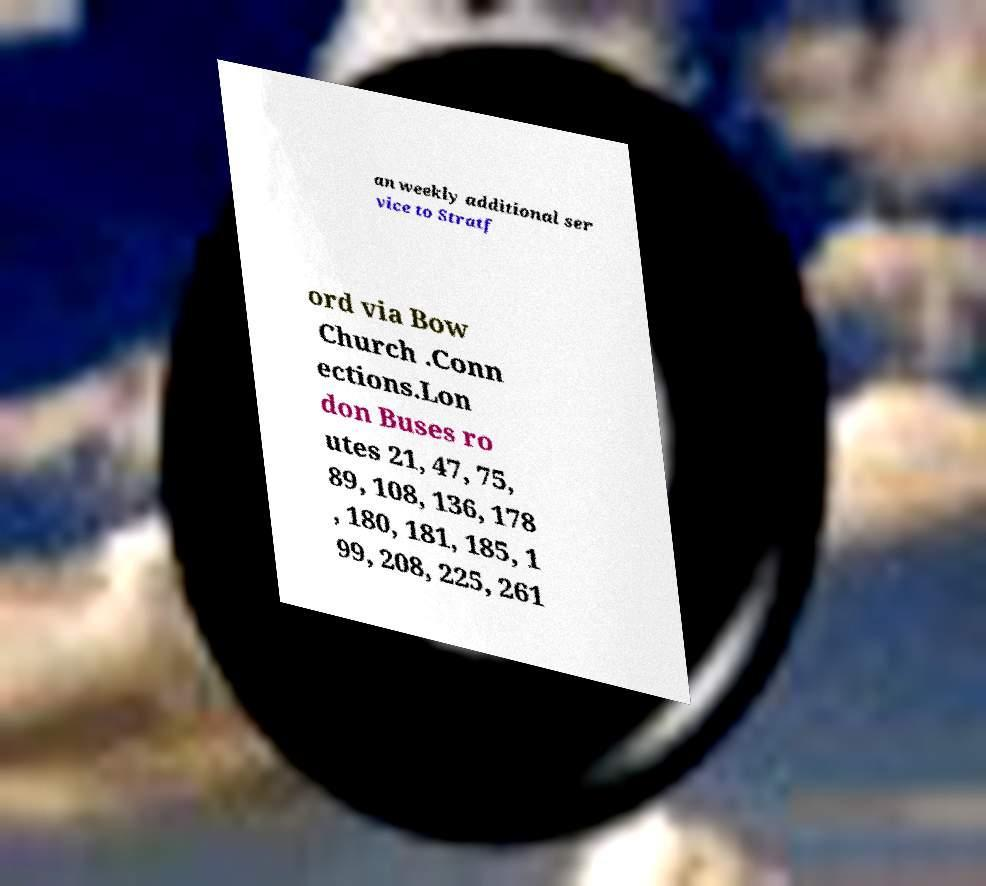I need the written content from this picture converted into text. Can you do that? an weekly additional ser vice to Stratf ord via Bow Church .Conn ections.Lon don Buses ro utes 21, 47, 75, 89, 108, 136, 178 , 180, 181, 185, 1 99, 208, 225, 261 